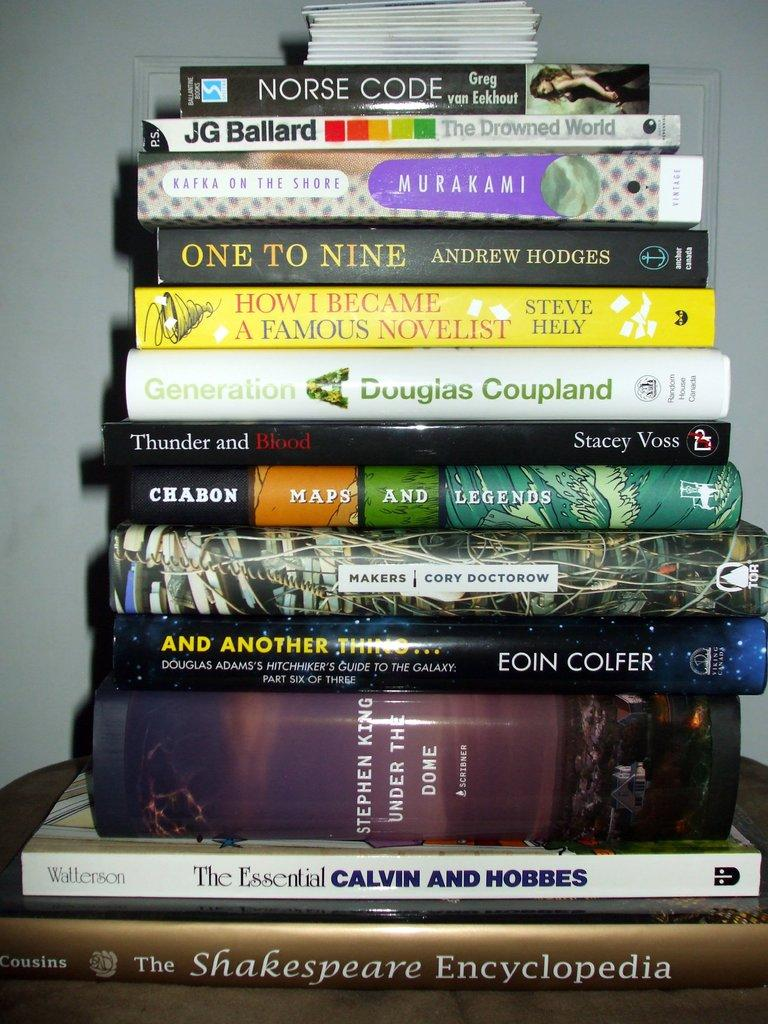Provide a one-sentence caption for the provided image. A stack of books with Norse Code by Greg van Eekout on top. 